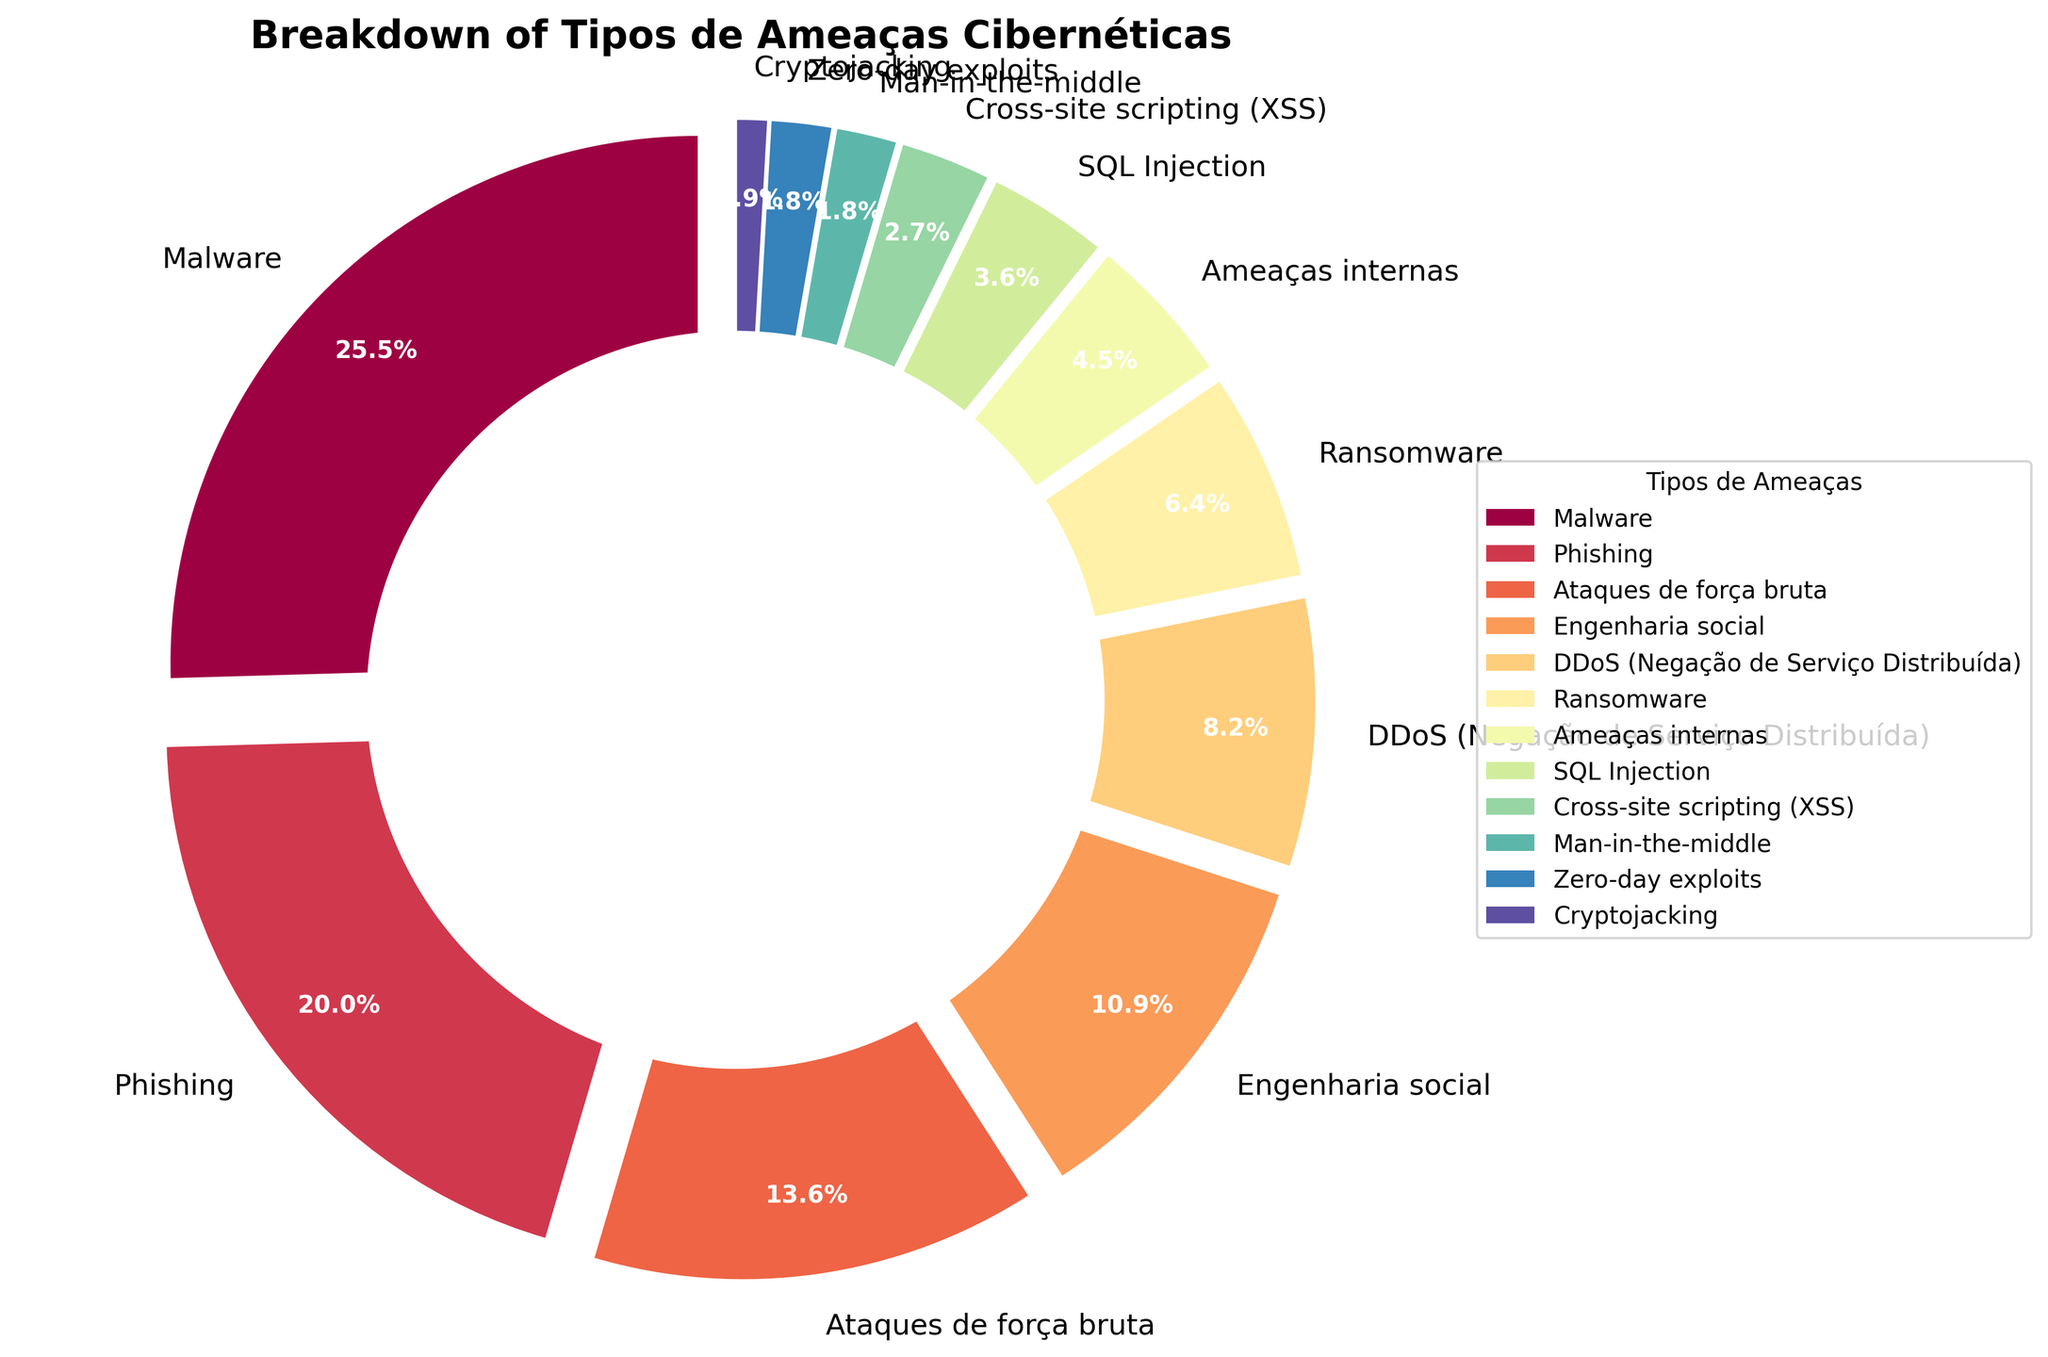Which tipo de ameaça cibernética enfrenta a maior porcentagem? Pela análise da figura, o setor com a maior porcentagem é aquele que ocupa a maior área da torta. Neste caso, Malware ocupa a maior porção.
Answer: Malware Qual é a diferença percentual entre ataques de Malware e Phishing? Comparando as porcentagens no gráfico, Malware representa 28% e Phishing 22%. A diferença entre eles é 28 - 22 = 6.
Answer: 6 Quais tipos de ameaças cibernéticas têm uma porcentagem menor que 5%? Ao observar a figura, os tipos de ameaças cibernéticas com porcentagens menores que 5% são: Ameaças internas, SQL Injection, Cross-site scripting (XSS), Man-in-the-middle, Zero-day exploits e Cryptojacking.
Answer: Ameaças internas, SQL Injection, Cross-site scripting (XSS), Man-in-the-middle, Zero-day exploits, Cryptojacking Qual é a soma das porcentagens das três ameaças cibernéticas menos comuns? As três ameaças menos comuns têm as porcentagens de 2% (Man-in-the-middle), 2% (Zero-day exploits) e 1% (Cryptojacking). Somando-as, temos 2 + 2 + 1 = 5.
Answer: 5 Qual é a categoria com uma diferença percentual de exatamente 10% em relação aos ataques de força bruta? Os ataques de força bruta têm 15%. A diferença percentual de 10% pode ser observada comparando com Engenharia social, que é de 12% (15 - 12 = 3) e DDoS, que é de 9% (15 - 9 = 6). Mas nenhuma dessas diferenças é exatamente 10%. Comparando com outras categorias, Phishing (15 - 22) também não resulta em 10%.
Answer: Não aplicável Como a soma das porcentagens de Engenharia social, Ameaças internas e Cross-site scripting (XSS) se compara com a de Phishing? Engenharia social tem 12%, Ameaças internas têm 5%, e Cross-site scripting (XSS) têm 3%. A soma é 12 + 5 + 3 = 20%. A porcentagem de Phishing é 22%. Portanto, 20 é menor que 22.
Answer: Menor Quais duas categorias somam até metade das ameaças totais (50%)? Inspeciona-se as maiores porcentagens até encontrar uma soma que chegue a 50%. Malware (28%) + Phishing (22%) somam exatamente 50%.
Answer: Malware, Phishing De que cor é representado o Ransomware no gráfico? Observa-se a cor do setor da torta que corresponde ao Ransomware, que pode ser identificado tanto pelo título quanto pela legenda do gráfico.
Answer: Depende da visualização específica, não pode ser determinado através de texto 